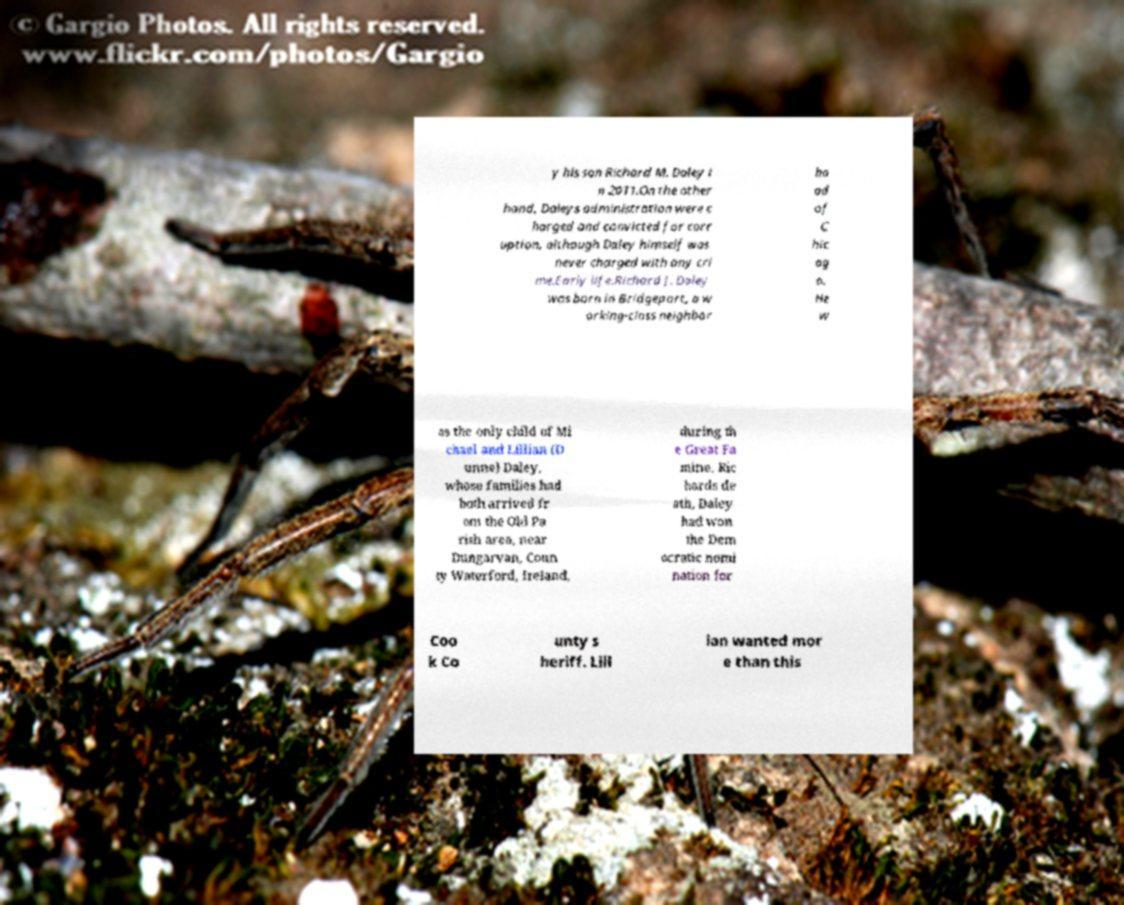Could you extract and type out the text from this image? y his son Richard M. Daley i n 2011.On the other hand, Daleys administration were c harged and convicted for corr uption, although Daley himself was never charged with any cri me.Early life.Richard J. Daley was born in Bridgeport, a w orking-class neighbor ho od of C hic ag o. He w as the only child of Mi chael and Lillian (D unne) Daley, whose families had both arrived fr om the Old Pa rish area, near Dungarvan, Coun ty Waterford, Ireland, during th e Great Fa mine. Ric hards de ath, Daley had won the Dem ocratic nomi nation for Coo k Co unty s heriff. Lill ian wanted mor e than this 